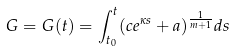<formula> <loc_0><loc_0><loc_500><loc_500>G = G ( t ) = \int _ { t _ { 0 } } ^ { t } ( c e ^ { \kappa s } + a ) ^ { \frac { 1 } { m + 1 } } d s</formula> 